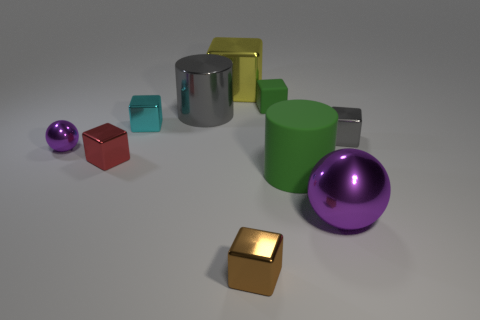Subtract all big blocks. How many blocks are left? 5 Subtract 1 balls. How many balls are left? 1 Subtract all green blocks. How many blocks are left? 5 Subtract all blocks. How many objects are left? 4 Subtract all cyan metallic things. Subtract all green cylinders. How many objects are left? 8 Add 4 tiny red metallic blocks. How many tiny red metallic blocks are left? 5 Add 5 tiny blocks. How many tiny blocks exist? 10 Subtract 1 gray cylinders. How many objects are left? 9 Subtract all cyan cylinders. Subtract all cyan balls. How many cylinders are left? 2 